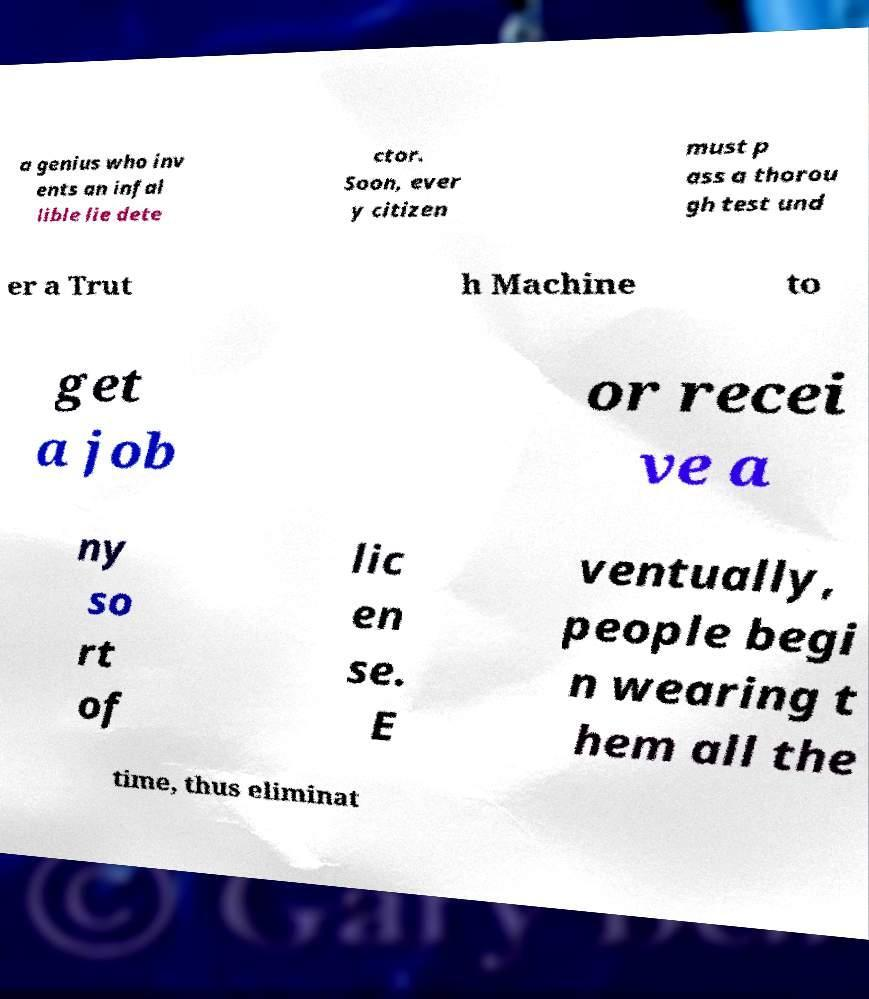Please identify and transcribe the text found in this image. a genius who inv ents an infal lible lie dete ctor. Soon, ever y citizen must p ass a thorou gh test und er a Trut h Machine to get a job or recei ve a ny so rt of lic en se. E ventually, people begi n wearing t hem all the time, thus eliminat 